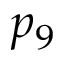<formula> <loc_0><loc_0><loc_500><loc_500>p _ { 9 }</formula> 